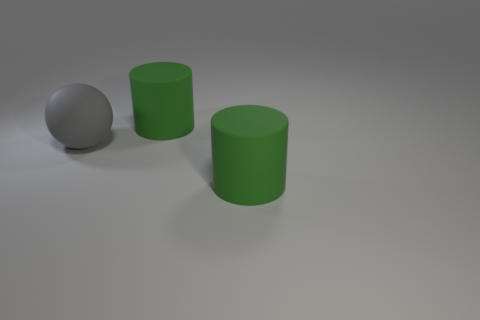Is there any other thing that has the same size as the ball?
Offer a very short reply. Yes. Is the size of the gray matte ball the same as the rubber object behind the gray matte ball?
Your answer should be compact. Yes. What number of big yellow matte things are there?
Give a very brief answer. 0. Do the rubber thing that is behind the rubber sphere and the rubber object in front of the gray ball have the same size?
Provide a succinct answer. Yes. How many big green cylinders have the same material as the big ball?
Ensure brevity in your answer.  2. How many objects are large purple matte cylinders or green cylinders?
Your response must be concise. 2. Are there any big things that are left of the big green object that is behind the gray matte sphere?
Offer a terse response. Yes. There is a rubber cylinder in front of the big gray matte ball; is its color the same as the thing behind the big gray thing?
Your response must be concise. Yes. There is a matte ball; are there any matte cylinders to the right of it?
Your answer should be compact. Yes. What material is the ball?
Provide a short and direct response. Rubber. 